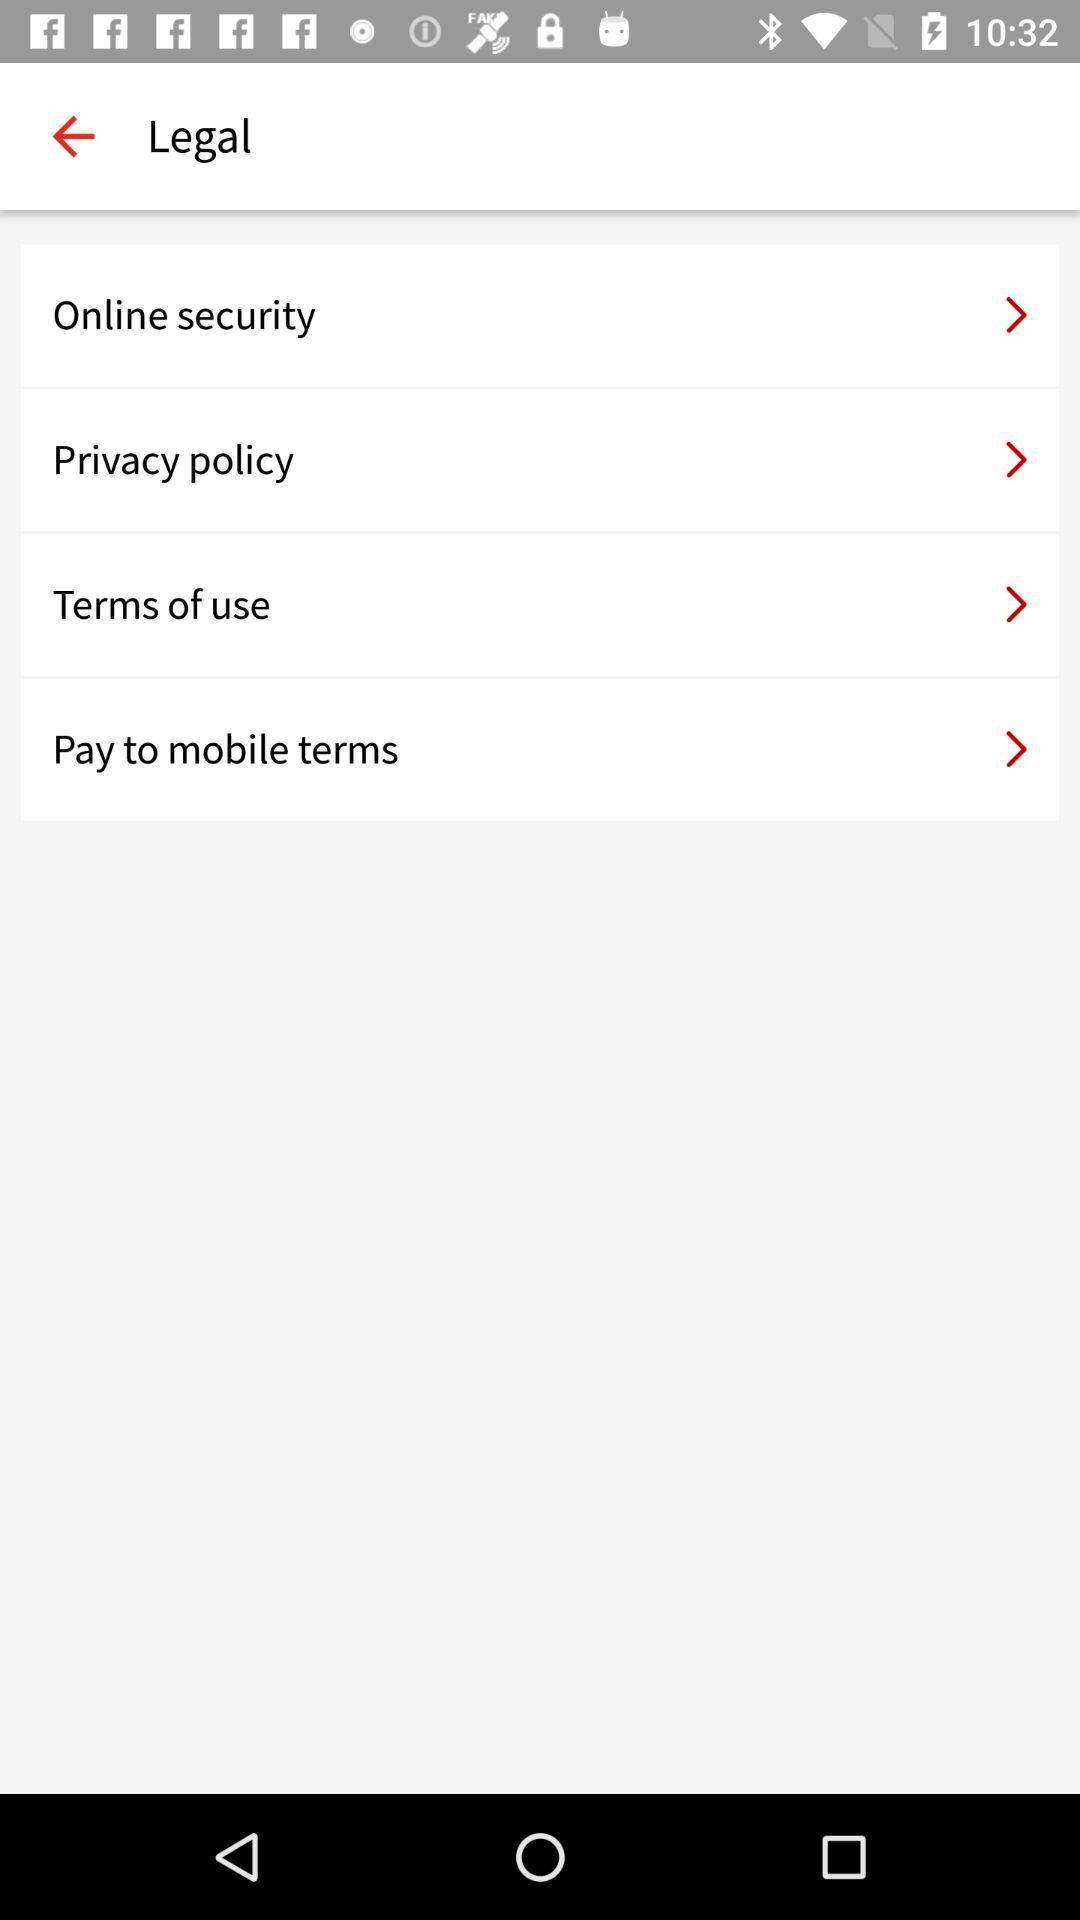How can the 'Terms of use' affect my usage of an app or service? The 'Terms of use' enforce certain rules and guidelines on how you should and shouldn't use the app or service. They might restrict certain behaviors, specify acceptable use cases, and outline consequences for violations. Adherence to these terms ensures you can continue to use the service without interruption and understand the legal implications of your actions within the platform's ecosystem. 